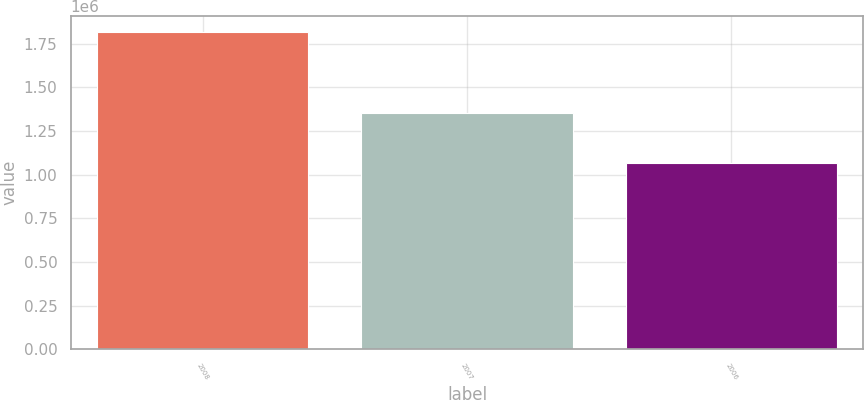Convert chart to OTSL. <chart><loc_0><loc_0><loc_500><loc_500><bar_chart><fcel>2008<fcel>2007<fcel>2006<nl><fcel>1.81884e+06<fcel>1.355e+06<fcel>1.06784e+06<nl></chart> 